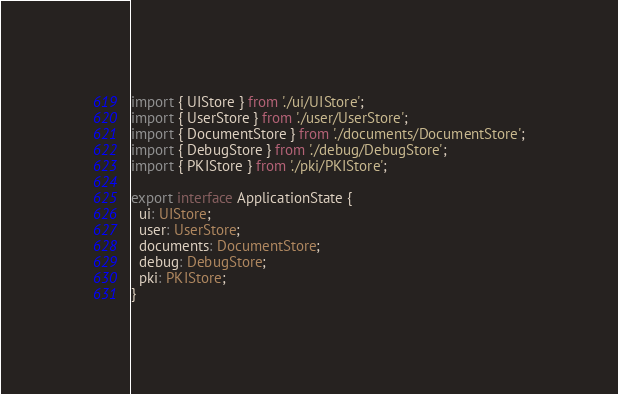<code> <loc_0><loc_0><loc_500><loc_500><_TypeScript_>import { UIStore } from './ui/UIStore';
import { UserStore } from './user/UserStore';
import { DocumentStore } from './documents/DocumentStore';
import { DebugStore } from './debug/DebugStore';
import { PKIStore } from './pki/PKIStore';

export interface ApplicationState {
  ui: UIStore;
  user: UserStore;
  documents: DocumentStore;
  debug: DebugStore;
  pki: PKIStore;
}
</code> 